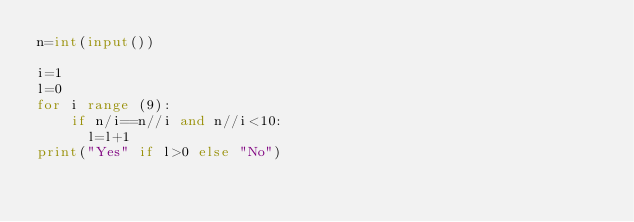<code> <loc_0><loc_0><loc_500><loc_500><_Python_>n=int(input())
 
i=1
l=0
for i range (9):
    if n/i==n//i and n//i<10:
      l=l+1
print("Yes" if l>0 else "No")</code> 